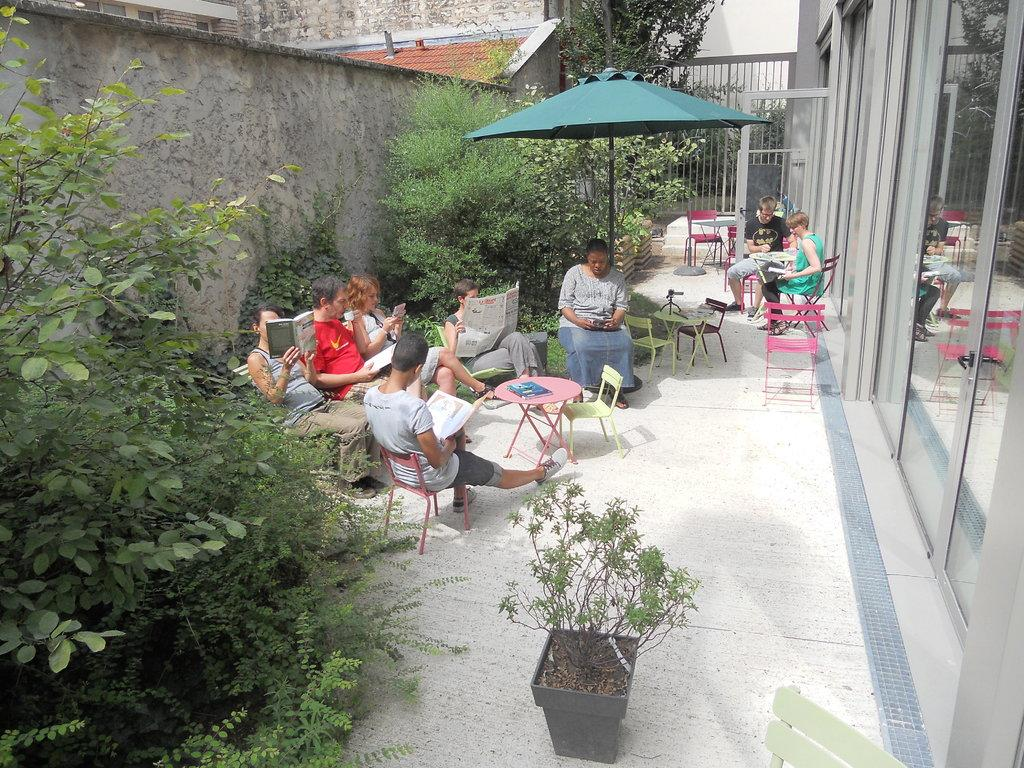What are the people in the image doing? The people are sitting on chairs and reading newspapers and books. What objects can be seen in the image that provide shelter or shade? There is an umbrella in the image. What type of vegetation is present in the image? There are bushes in the image. What architectural feature can be seen in the image? There is a glass door in the image. What type of sand can be seen on the floor in the image? There is no sand present in the image; it features people sitting on chairs and reading newspapers and books. 